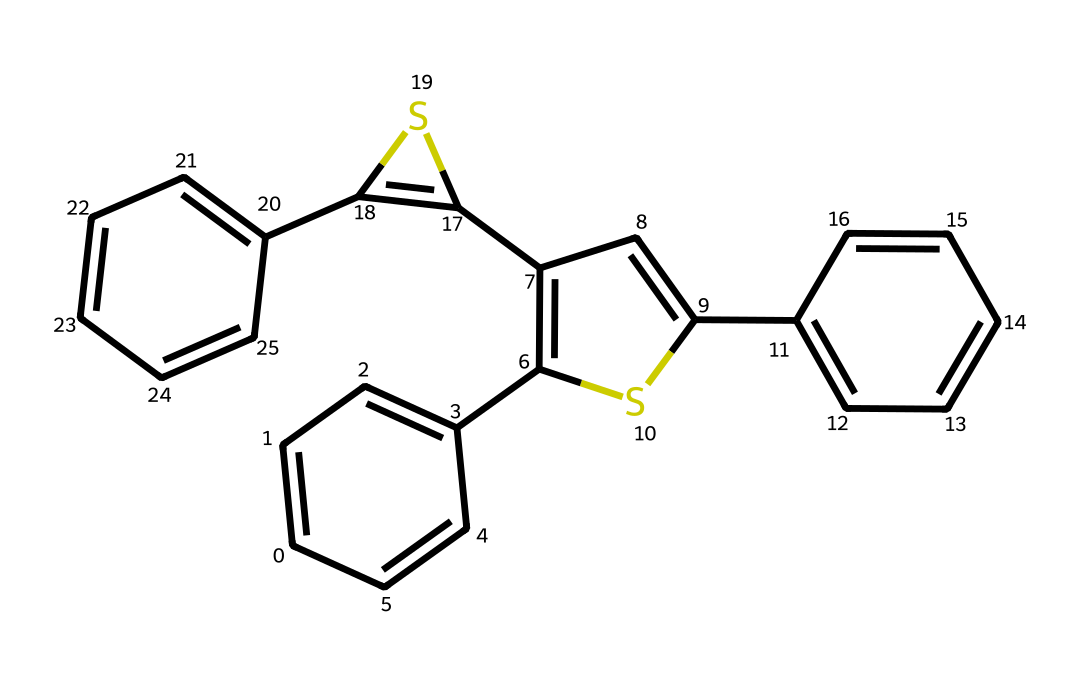What is the molecular formula of this compound? Analyzing the SMILES representation, we can count the number of carbon (C) and hydrogen (H) atoms in the structure. The SMILES indicates 20 carbon atoms and 16 hydrogen atoms. Therefore, the molecular formula is determined from these counts.
Answer: C20H16 How many rings are present in the structure? Looking at the SMILES representation, we can identify multiple instances of ring closures: the notation 'C1', 'C2', 'C3', and 'C4' suggests there are several cyclic components. By counting these, we find that there are four distinct rings in the structure.
Answer: 4 What type of photochemical reaction does diarylethene undergo? Diarylethene is known for undergoing photoisomerization, where the compound can switch between two forms upon exposure to light. This reaction involves the closed form converting to the open form and vice versa.
Answer: photoisomerization Which part of this structure is responsible for the photochromic property? The double bonds in the structure, particularly at the junctions of the rings, are critically involved in the photochromic behavior, as they enable the bond formation and breaking necessary for isomerization when exposed to light.
Answer: double bonds Which functional groups are present in the molecule? Analyzing the SMILES representation reveals a central structure that provides recognition of functional groups. In this case, the structure predominantly comprises aromatic rings, which can be classified within the broader category of phenyl groups.
Answer: phenyl groups What is the significance of the sulfur atoms in this compound? The sulfur atoms in the molecule usually play a significant role in stabilizing the structure and influencing the electronic properties, which can affect the efficiency of light-induced switching in optical applications.
Answer: stabilize structure 